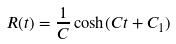<formula> <loc_0><loc_0><loc_500><loc_500>R ( t ) = \frac { 1 } { C } \cosh ( C t + C _ { 1 } )</formula> 